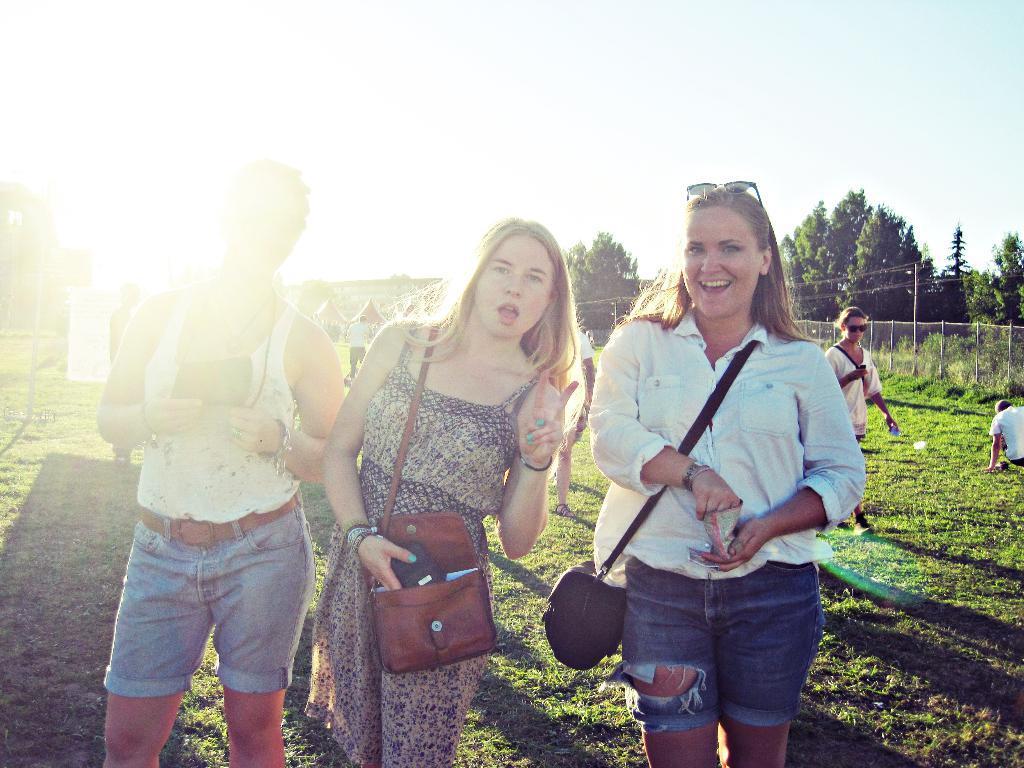In one or two sentences, can you explain what this image depicts? In this image, in the middle, we can see three people are standing on the grass. In the background, we can see a group of people, net fence, electric pole, electric wires, trees, plants. In the background, we can also see white color. At the top, we can see a sky, at the bottom, we can see some plants and a grass. 